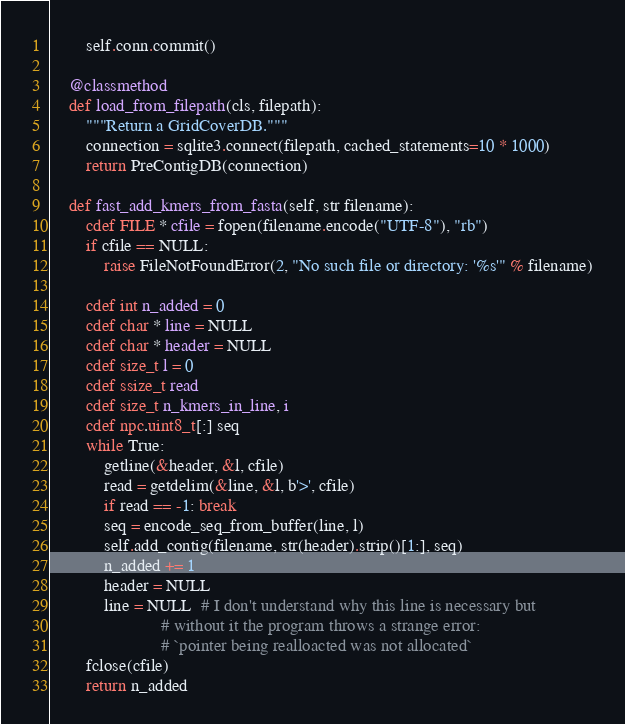<code> <loc_0><loc_0><loc_500><loc_500><_Cython_>        self.conn.commit()

    @classmethod
    def load_from_filepath(cls, filepath):
        """Return a GridCoverDB."""
        connection = sqlite3.connect(filepath, cached_statements=10 * 1000)
        return PreContigDB(connection)

    def fast_add_kmers_from_fasta(self, str filename):
        cdef FILE * cfile = fopen(filename.encode("UTF-8"), "rb")
        if cfile == NULL:
            raise FileNotFoundError(2, "No such file or directory: '%s'" % filename)

        cdef int n_added = 0
        cdef char * line = NULL
        cdef char * header = NULL
        cdef size_t l = 0
        cdef ssize_t read
        cdef size_t n_kmers_in_line, i
        cdef npc.uint8_t[:] seq
        while True:
            getline(&header, &l, cfile)
            read = getdelim(&line, &l, b'>', cfile)
            if read == -1: break
            seq = encode_seq_from_buffer(line, l)
            self.add_contig(filename, str(header).strip()[1:], seq)
            n_added += 1
            header = NULL
            line = NULL  # I don't understand why this line is necessary but
                         # without it the program throws a strange error: 
                         # `pointer being realloacted was not allocated`
        fclose(cfile)
        return n_added
</code> 